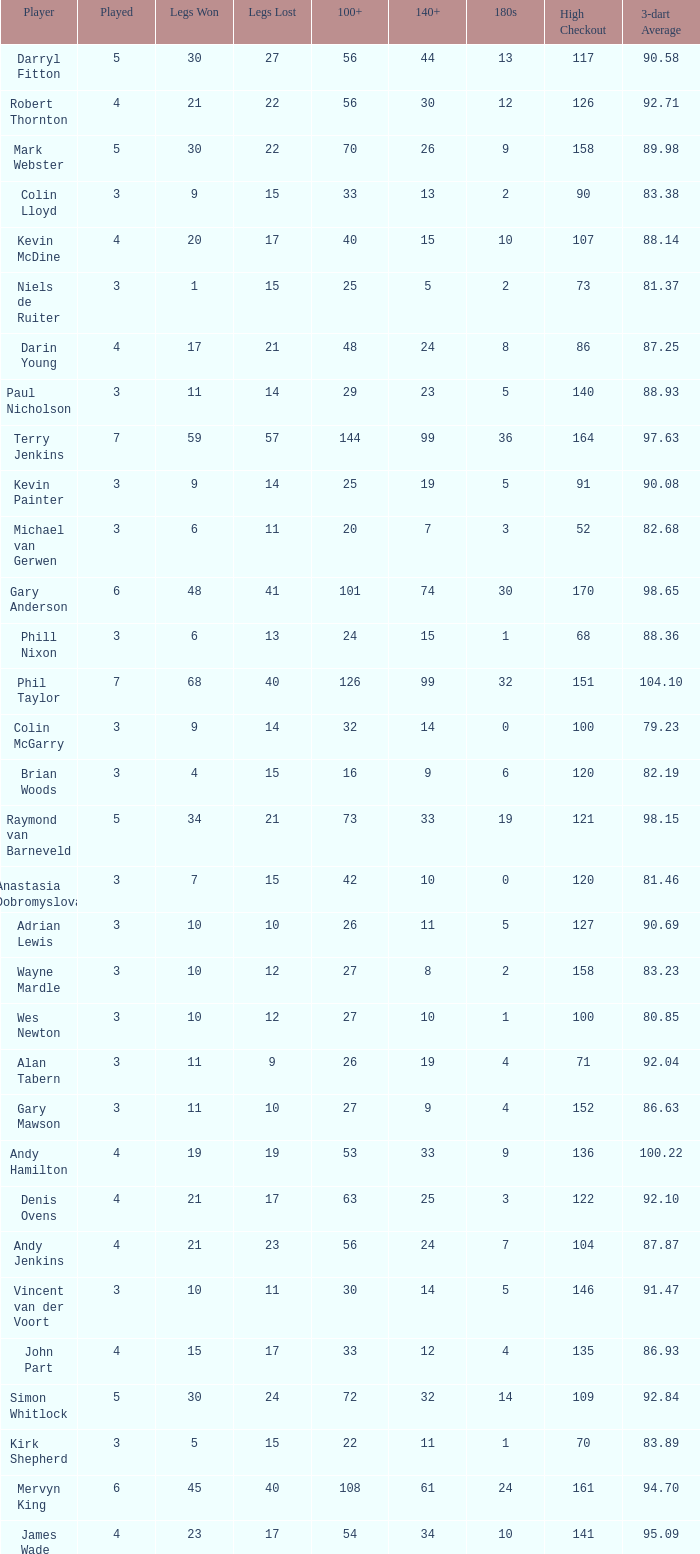What is the total number of 3-dart average when legs lost is larger than 41, and played is larger than 7? 0.0. 